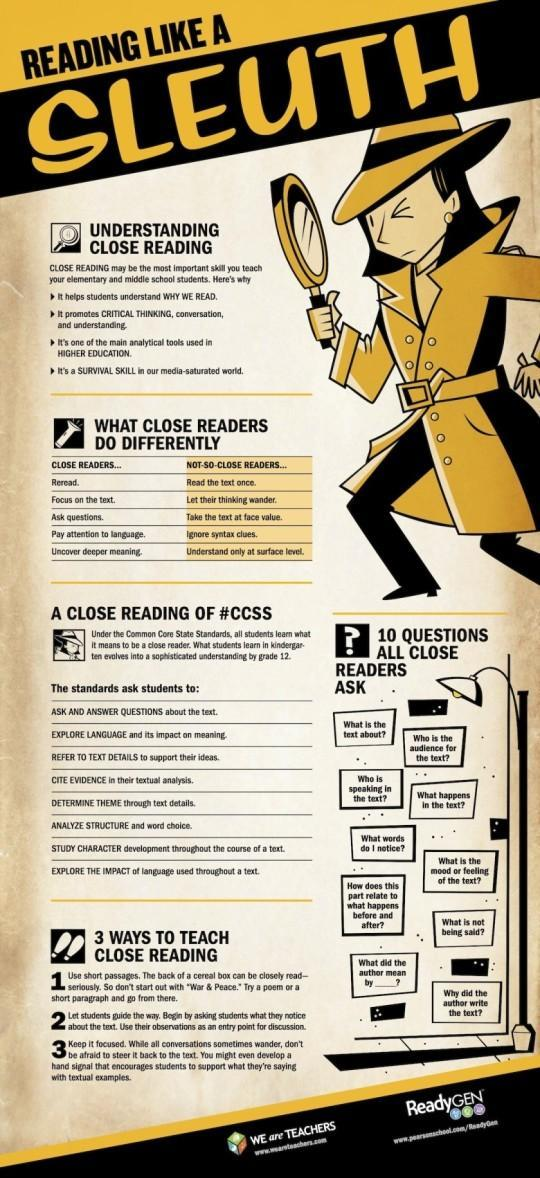who uncovers deeper meaning
Answer the question with a short phrase. close readers who asks what happens in the text close readers What promotes critical thinking Close reading how many benefits have been identified by close reading 4 Who ignores syntax clues not-so-close readers who pays attention to language close readers who let their thinking wander not-so-close readers what is the colour of the pant of the sleuth, black or yellow black 